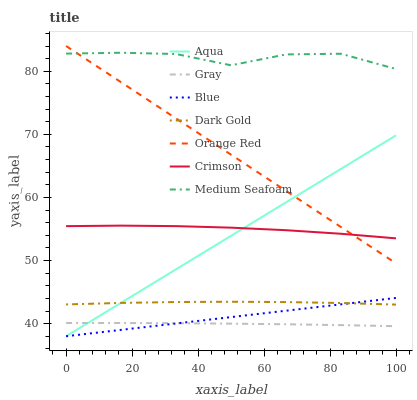Does Gray have the minimum area under the curve?
Answer yes or no. Yes. Does Medium Seafoam have the maximum area under the curve?
Answer yes or no. Yes. Does Dark Gold have the minimum area under the curve?
Answer yes or no. No. Does Dark Gold have the maximum area under the curve?
Answer yes or no. No. Is Blue the smoothest?
Answer yes or no. Yes. Is Medium Seafoam the roughest?
Answer yes or no. Yes. Is Gray the smoothest?
Answer yes or no. No. Is Gray the roughest?
Answer yes or no. No. Does Blue have the lowest value?
Answer yes or no. Yes. Does Gray have the lowest value?
Answer yes or no. No. Does Orange Red have the highest value?
Answer yes or no. Yes. Does Dark Gold have the highest value?
Answer yes or no. No. Is Blue less than Crimson?
Answer yes or no. Yes. Is Medium Seafoam greater than Aqua?
Answer yes or no. Yes. Does Aqua intersect Dark Gold?
Answer yes or no. Yes. Is Aqua less than Dark Gold?
Answer yes or no. No. Is Aqua greater than Dark Gold?
Answer yes or no. No. Does Blue intersect Crimson?
Answer yes or no. No. 